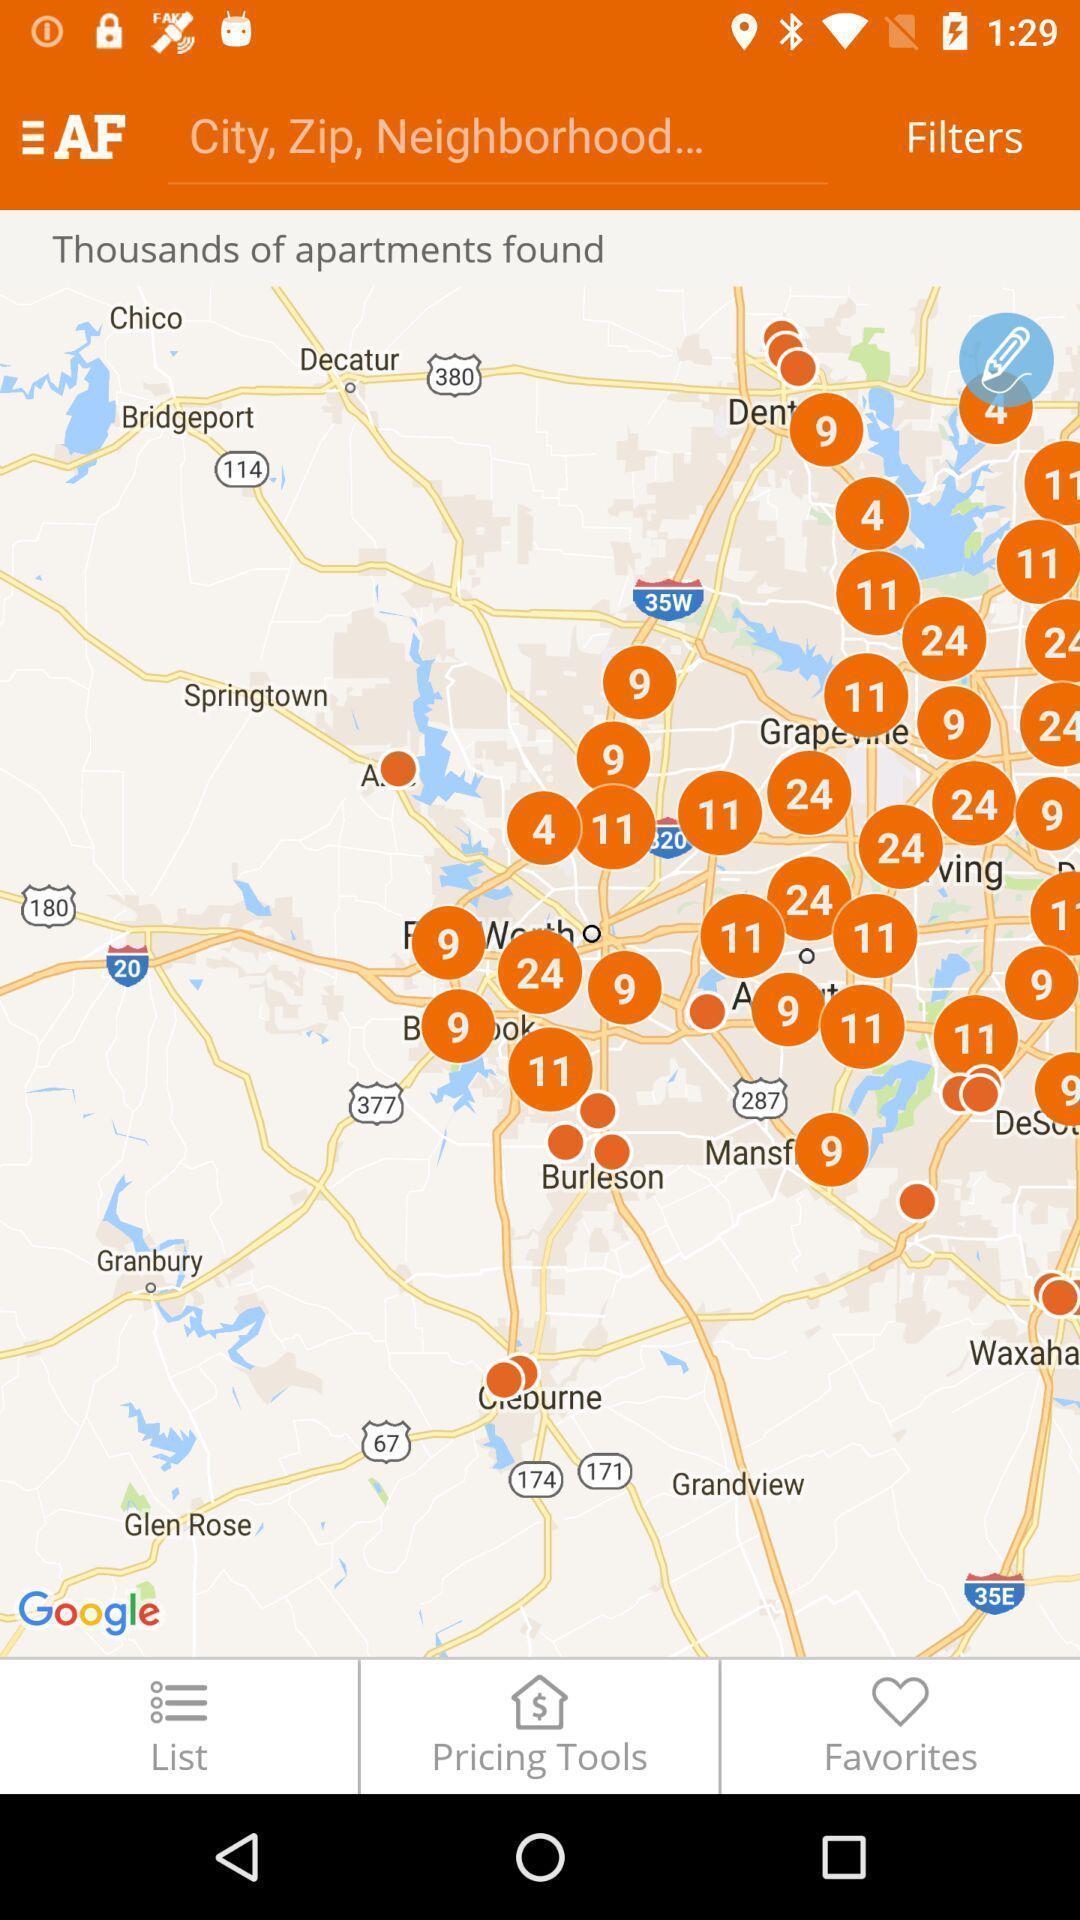Describe the key features of this screenshot. Screen shows different options in map. 